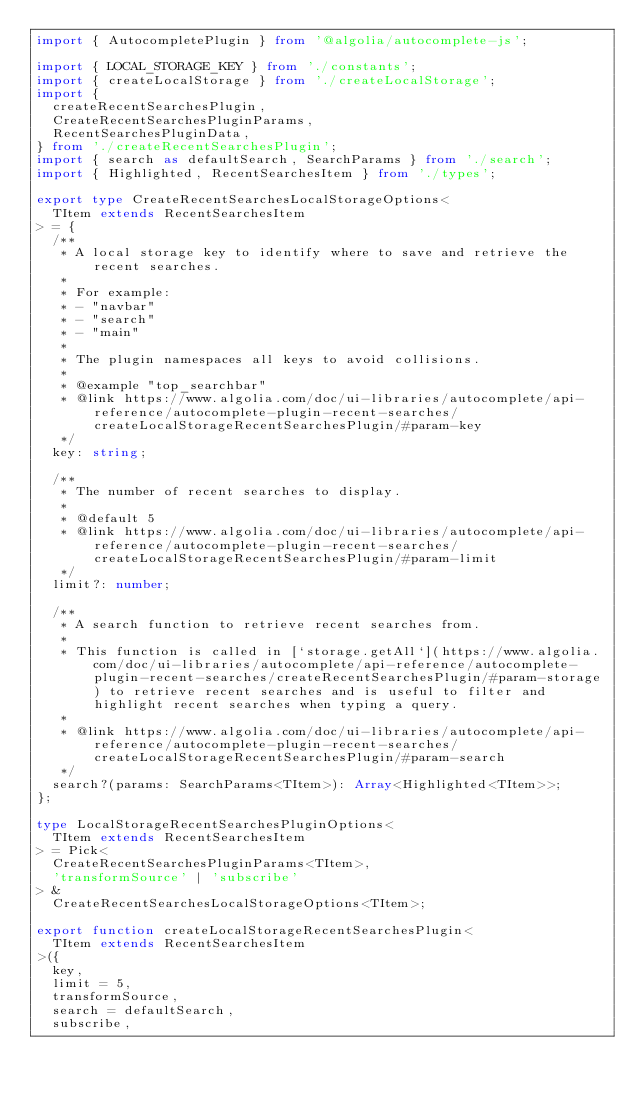<code> <loc_0><loc_0><loc_500><loc_500><_TypeScript_>import { AutocompletePlugin } from '@algolia/autocomplete-js';

import { LOCAL_STORAGE_KEY } from './constants';
import { createLocalStorage } from './createLocalStorage';
import {
  createRecentSearchesPlugin,
  CreateRecentSearchesPluginParams,
  RecentSearchesPluginData,
} from './createRecentSearchesPlugin';
import { search as defaultSearch, SearchParams } from './search';
import { Highlighted, RecentSearchesItem } from './types';

export type CreateRecentSearchesLocalStorageOptions<
  TItem extends RecentSearchesItem
> = {
  /**
   * A local storage key to identify where to save and retrieve the recent searches.
   *
   * For example:
   * - "navbar"
   * - "search"
   * - "main"
   *
   * The plugin namespaces all keys to avoid collisions.
   *
   * @example "top_searchbar"
   * @link https://www.algolia.com/doc/ui-libraries/autocomplete/api-reference/autocomplete-plugin-recent-searches/createLocalStorageRecentSearchesPlugin/#param-key
   */
  key: string;

  /**
   * The number of recent searches to display.
   *
   * @default 5
   * @link https://www.algolia.com/doc/ui-libraries/autocomplete/api-reference/autocomplete-plugin-recent-searches/createLocalStorageRecentSearchesPlugin/#param-limit
   */
  limit?: number;

  /**
   * A search function to retrieve recent searches from.
   *
   * This function is called in [`storage.getAll`](https://www.algolia.com/doc/ui-libraries/autocomplete/api-reference/autocomplete-plugin-recent-searches/createRecentSearchesPlugin/#param-storage) to retrieve recent searches and is useful to filter and highlight recent searches when typing a query.
   *
   * @link https://www.algolia.com/doc/ui-libraries/autocomplete/api-reference/autocomplete-plugin-recent-searches/createLocalStorageRecentSearchesPlugin/#param-search
   */
  search?(params: SearchParams<TItem>): Array<Highlighted<TItem>>;
};

type LocalStorageRecentSearchesPluginOptions<
  TItem extends RecentSearchesItem
> = Pick<
  CreateRecentSearchesPluginParams<TItem>,
  'transformSource' | 'subscribe'
> &
  CreateRecentSearchesLocalStorageOptions<TItem>;

export function createLocalStorageRecentSearchesPlugin<
  TItem extends RecentSearchesItem
>({
  key,
  limit = 5,
  transformSource,
  search = defaultSearch,
  subscribe,</code> 